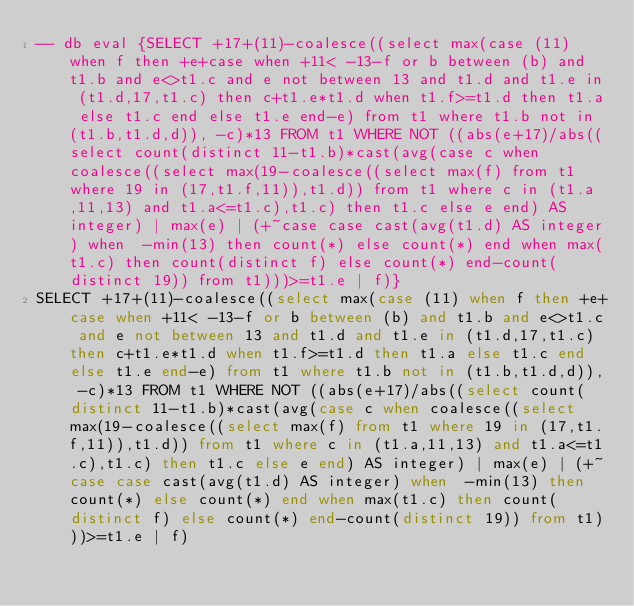<code> <loc_0><loc_0><loc_500><loc_500><_SQL_>-- db eval {SELECT +17+(11)-coalesce((select max(case (11) when f then +e+case when +11< -13-f or b between (b) and t1.b and e<>t1.c and e not between 13 and t1.d and t1.e in (t1.d,17,t1.c) then c+t1.e*t1.d when t1.f>=t1.d then t1.a else t1.c end else t1.e end-e) from t1 where t1.b not in (t1.b,t1.d,d)), -c)*13 FROM t1 WHERE NOT ((abs(e+17)/abs((select count(distinct 11-t1.b)*cast(avg(case c when coalesce((select max(19-coalesce((select max(f) from t1 where 19 in (17,t1.f,11)),t1.d)) from t1 where c in (t1.a,11,13) and t1.a<=t1.c),t1.c) then t1.c else e end) AS integer) | max(e) | (+~case case cast(avg(t1.d) AS integer) when  -min(13) then count(*) else count(*) end when max(t1.c) then count(distinct f) else count(*) end-count(distinct 19)) from t1)))>=t1.e | f)}
SELECT +17+(11)-coalesce((select max(case (11) when f then +e+case when +11< -13-f or b between (b) and t1.b and e<>t1.c and e not between 13 and t1.d and t1.e in (t1.d,17,t1.c) then c+t1.e*t1.d when t1.f>=t1.d then t1.a else t1.c end else t1.e end-e) from t1 where t1.b not in (t1.b,t1.d,d)), -c)*13 FROM t1 WHERE NOT ((abs(e+17)/abs((select count(distinct 11-t1.b)*cast(avg(case c when coalesce((select max(19-coalesce((select max(f) from t1 where 19 in (17,t1.f,11)),t1.d)) from t1 where c in (t1.a,11,13) and t1.a<=t1.c),t1.c) then t1.c else e end) AS integer) | max(e) | (+~case case cast(avg(t1.d) AS integer) when  -min(13) then count(*) else count(*) end when max(t1.c) then count(distinct f) else count(*) end-count(distinct 19)) from t1)))>=t1.e | f)</code> 